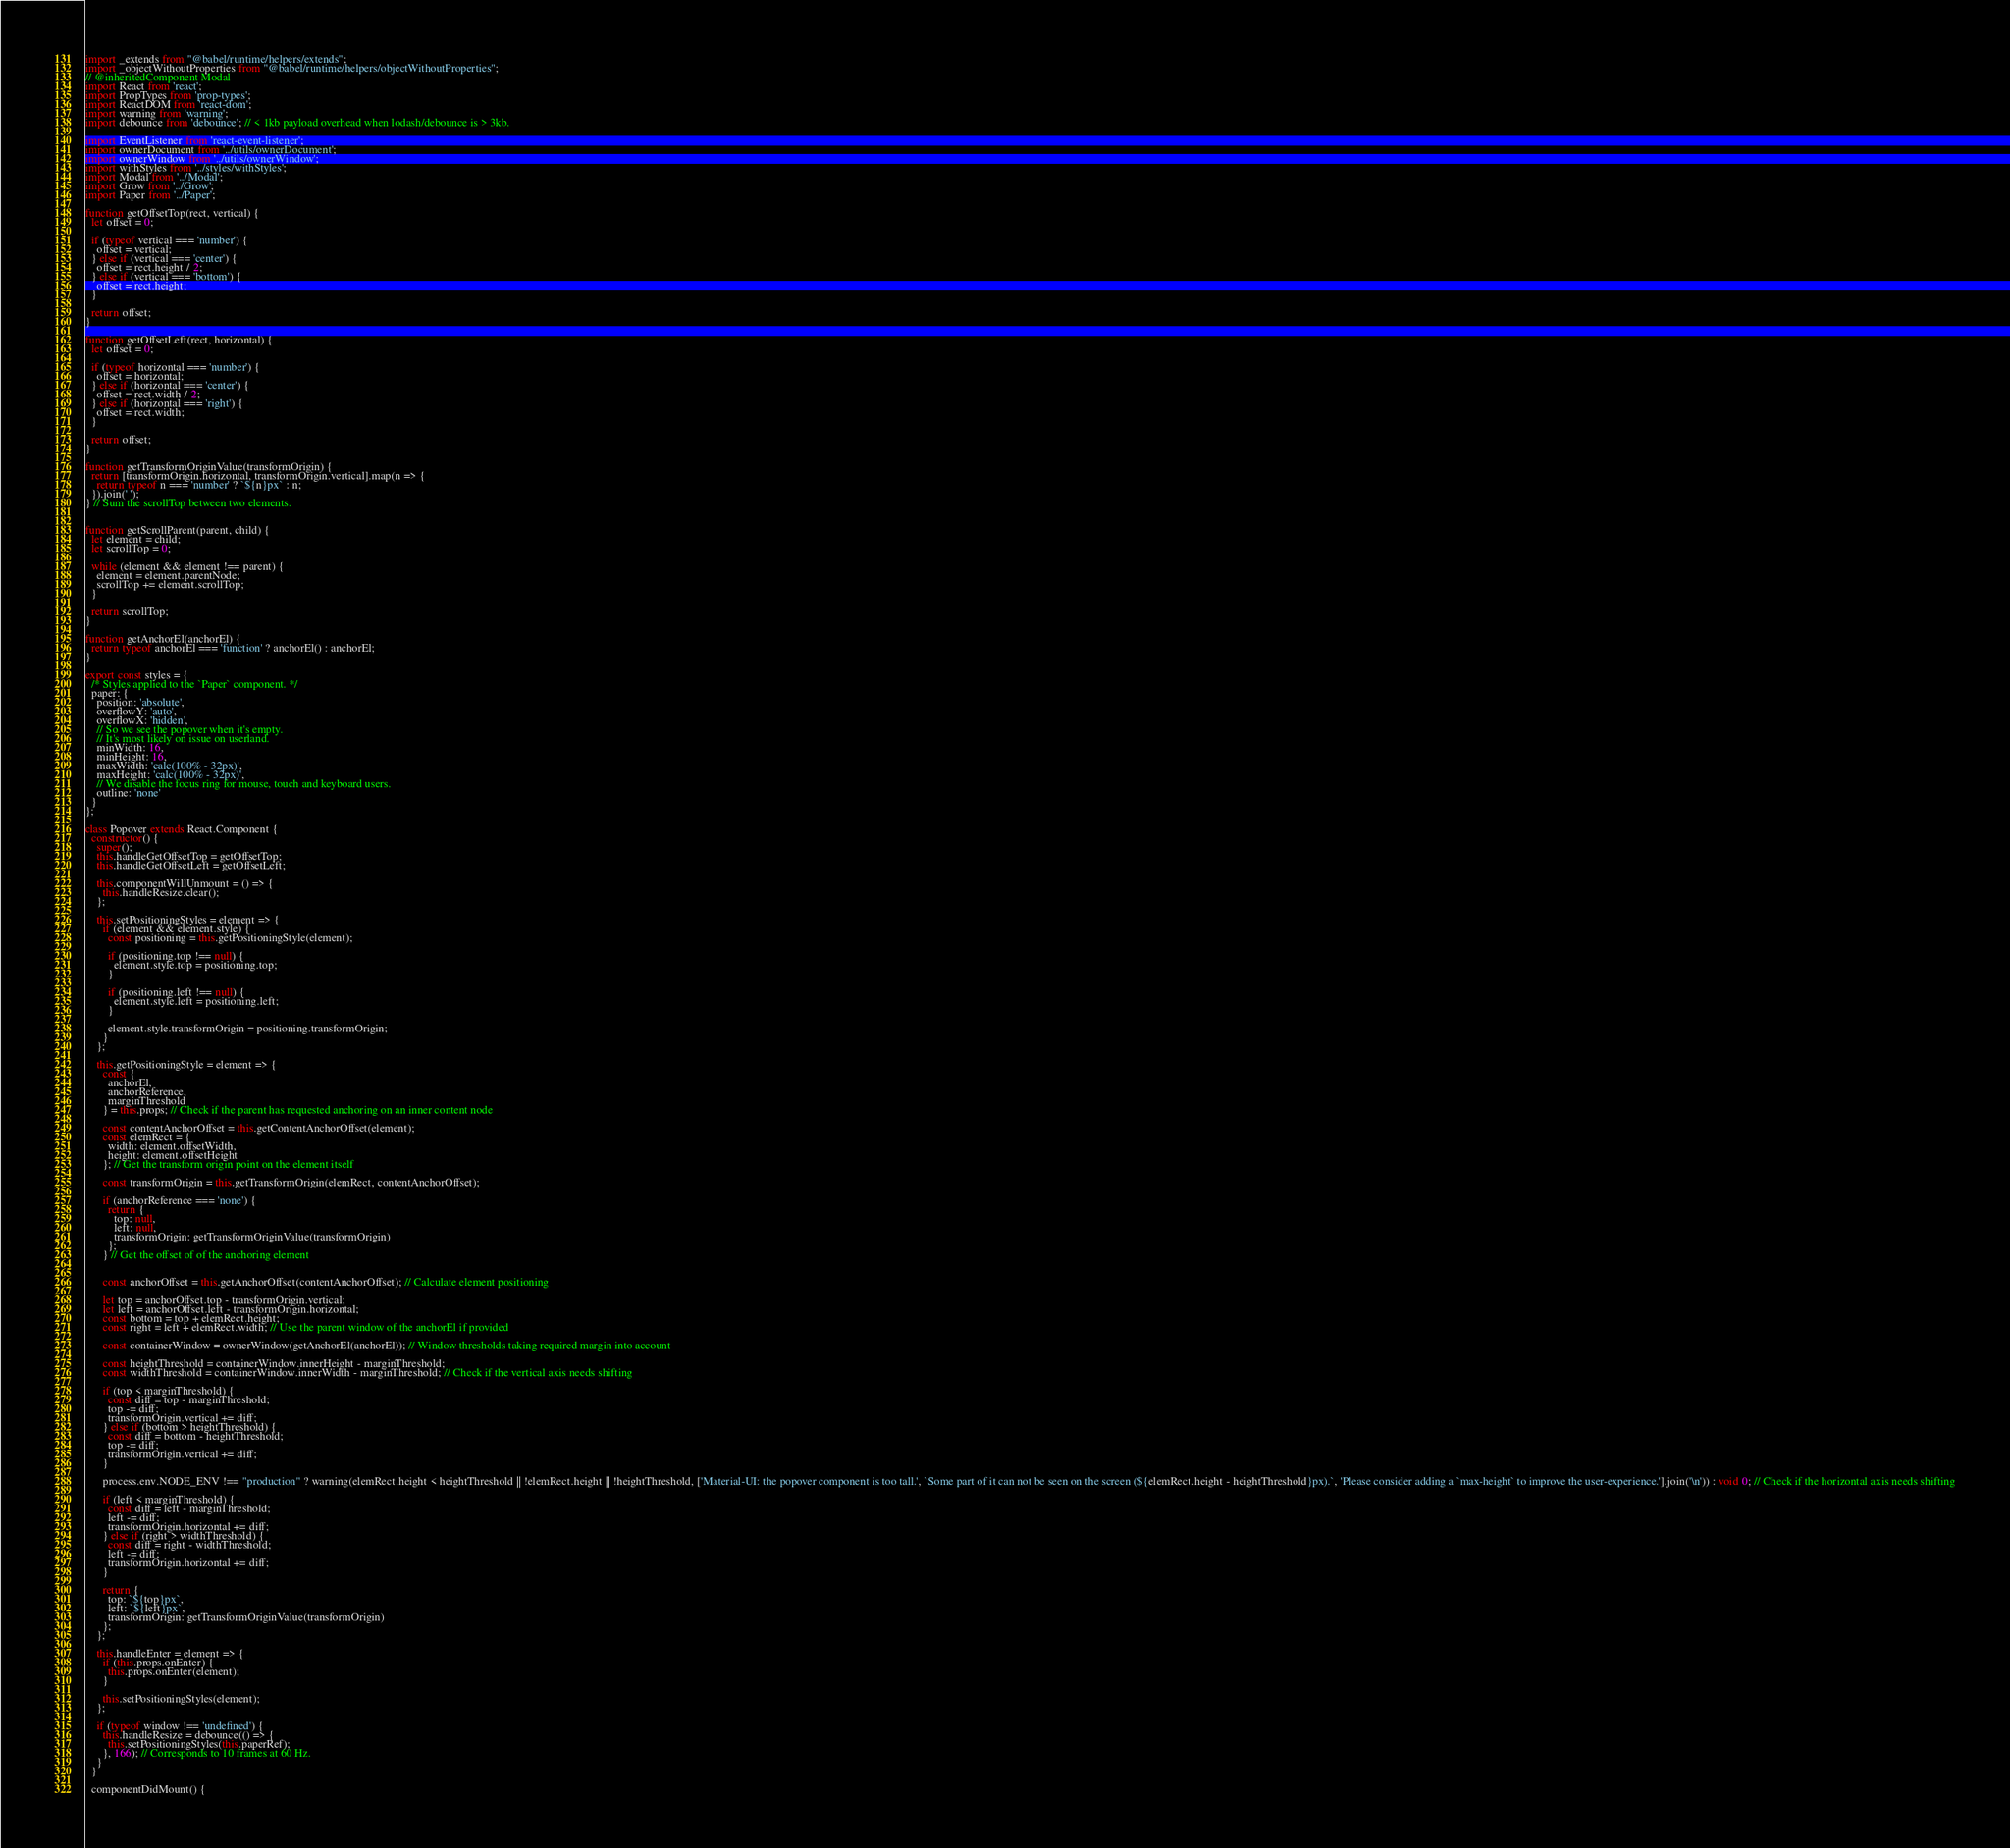<code> <loc_0><loc_0><loc_500><loc_500><_JavaScript_>import _extends from "@babel/runtime/helpers/extends";
import _objectWithoutProperties from "@babel/runtime/helpers/objectWithoutProperties";
// @inheritedComponent Modal
import React from 'react';
import PropTypes from 'prop-types';
import ReactDOM from 'react-dom';
import warning from 'warning';
import debounce from 'debounce'; // < 1kb payload overhead when lodash/debounce is > 3kb.

import EventListener from 'react-event-listener';
import ownerDocument from '../utils/ownerDocument';
import ownerWindow from '../utils/ownerWindow';
import withStyles from '../styles/withStyles';
import Modal from '../Modal';
import Grow from '../Grow';
import Paper from '../Paper';

function getOffsetTop(rect, vertical) {
  let offset = 0;

  if (typeof vertical === 'number') {
    offset = vertical;
  } else if (vertical === 'center') {
    offset = rect.height / 2;
  } else if (vertical === 'bottom') {
    offset = rect.height;
  }

  return offset;
}

function getOffsetLeft(rect, horizontal) {
  let offset = 0;

  if (typeof horizontal === 'number') {
    offset = horizontal;
  } else if (horizontal === 'center') {
    offset = rect.width / 2;
  } else if (horizontal === 'right') {
    offset = rect.width;
  }

  return offset;
}

function getTransformOriginValue(transformOrigin) {
  return [transformOrigin.horizontal, transformOrigin.vertical].map(n => {
    return typeof n === 'number' ? `${n}px` : n;
  }).join(' ');
} // Sum the scrollTop between two elements.


function getScrollParent(parent, child) {
  let element = child;
  let scrollTop = 0;

  while (element && element !== parent) {
    element = element.parentNode;
    scrollTop += element.scrollTop;
  }

  return scrollTop;
}

function getAnchorEl(anchorEl) {
  return typeof anchorEl === 'function' ? anchorEl() : anchorEl;
}

export const styles = {
  /* Styles applied to the `Paper` component. */
  paper: {
    position: 'absolute',
    overflowY: 'auto',
    overflowX: 'hidden',
    // So we see the popover when it's empty.
    // It's most likely on issue on userland.
    minWidth: 16,
    minHeight: 16,
    maxWidth: 'calc(100% - 32px)',
    maxHeight: 'calc(100% - 32px)',
    // We disable the focus ring for mouse, touch and keyboard users.
    outline: 'none'
  }
};

class Popover extends React.Component {
  constructor() {
    super();
    this.handleGetOffsetTop = getOffsetTop;
    this.handleGetOffsetLeft = getOffsetLeft;

    this.componentWillUnmount = () => {
      this.handleResize.clear();
    };

    this.setPositioningStyles = element => {
      if (element && element.style) {
        const positioning = this.getPositioningStyle(element);

        if (positioning.top !== null) {
          element.style.top = positioning.top;
        }

        if (positioning.left !== null) {
          element.style.left = positioning.left;
        }

        element.style.transformOrigin = positioning.transformOrigin;
      }
    };

    this.getPositioningStyle = element => {
      const {
        anchorEl,
        anchorReference,
        marginThreshold
      } = this.props; // Check if the parent has requested anchoring on an inner content node

      const contentAnchorOffset = this.getContentAnchorOffset(element);
      const elemRect = {
        width: element.offsetWidth,
        height: element.offsetHeight
      }; // Get the transform origin point on the element itself

      const transformOrigin = this.getTransformOrigin(elemRect, contentAnchorOffset);

      if (anchorReference === 'none') {
        return {
          top: null,
          left: null,
          transformOrigin: getTransformOriginValue(transformOrigin)
        };
      } // Get the offset of of the anchoring element


      const anchorOffset = this.getAnchorOffset(contentAnchorOffset); // Calculate element positioning

      let top = anchorOffset.top - transformOrigin.vertical;
      let left = anchorOffset.left - transformOrigin.horizontal;
      const bottom = top + elemRect.height;
      const right = left + elemRect.width; // Use the parent window of the anchorEl if provided

      const containerWindow = ownerWindow(getAnchorEl(anchorEl)); // Window thresholds taking required margin into account

      const heightThreshold = containerWindow.innerHeight - marginThreshold;
      const widthThreshold = containerWindow.innerWidth - marginThreshold; // Check if the vertical axis needs shifting

      if (top < marginThreshold) {
        const diff = top - marginThreshold;
        top -= diff;
        transformOrigin.vertical += diff;
      } else if (bottom > heightThreshold) {
        const diff = bottom - heightThreshold;
        top -= diff;
        transformOrigin.vertical += diff;
      }

      process.env.NODE_ENV !== "production" ? warning(elemRect.height < heightThreshold || !elemRect.height || !heightThreshold, ['Material-UI: the popover component is too tall.', `Some part of it can not be seen on the screen (${elemRect.height - heightThreshold}px).`, 'Please consider adding a `max-height` to improve the user-experience.'].join('\n')) : void 0; // Check if the horizontal axis needs shifting

      if (left < marginThreshold) {
        const diff = left - marginThreshold;
        left -= diff;
        transformOrigin.horizontal += diff;
      } else if (right > widthThreshold) {
        const diff = right - widthThreshold;
        left -= diff;
        transformOrigin.horizontal += diff;
      }

      return {
        top: `${top}px`,
        left: `${left}px`,
        transformOrigin: getTransformOriginValue(transformOrigin)
      };
    };

    this.handleEnter = element => {
      if (this.props.onEnter) {
        this.props.onEnter(element);
      }

      this.setPositioningStyles(element);
    };

    if (typeof window !== 'undefined') {
      this.handleResize = debounce(() => {
        this.setPositioningStyles(this.paperRef);
      }, 166); // Corresponds to 10 frames at 60 Hz.
    }
  }

  componentDidMount() {</code> 